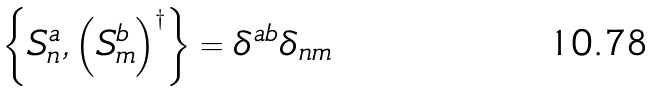<formula> <loc_0><loc_0><loc_500><loc_500>\left \{ S _ { n } ^ { a } , \left ( S _ { m } ^ { b } \right ) ^ { \dagger } \right \} = \delta ^ { a b } \delta _ { n m } \,</formula> 